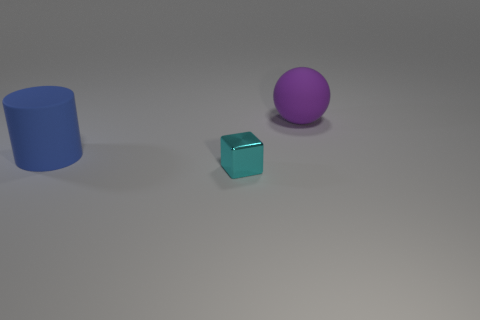Subtract all cylinders. How many objects are left? 2 Add 3 tiny cyan shiny cubes. How many objects exist? 6 Subtract all gray cylinders. Subtract all cyan spheres. How many cylinders are left? 1 Subtract all tiny red cylinders. Subtract all cyan things. How many objects are left? 2 Add 1 tiny cyan metal blocks. How many tiny cyan metal blocks are left? 2 Add 2 tiny cyan things. How many tiny cyan things exist? 3 Subtract 0 gray spheres. How many objects are left? 3 